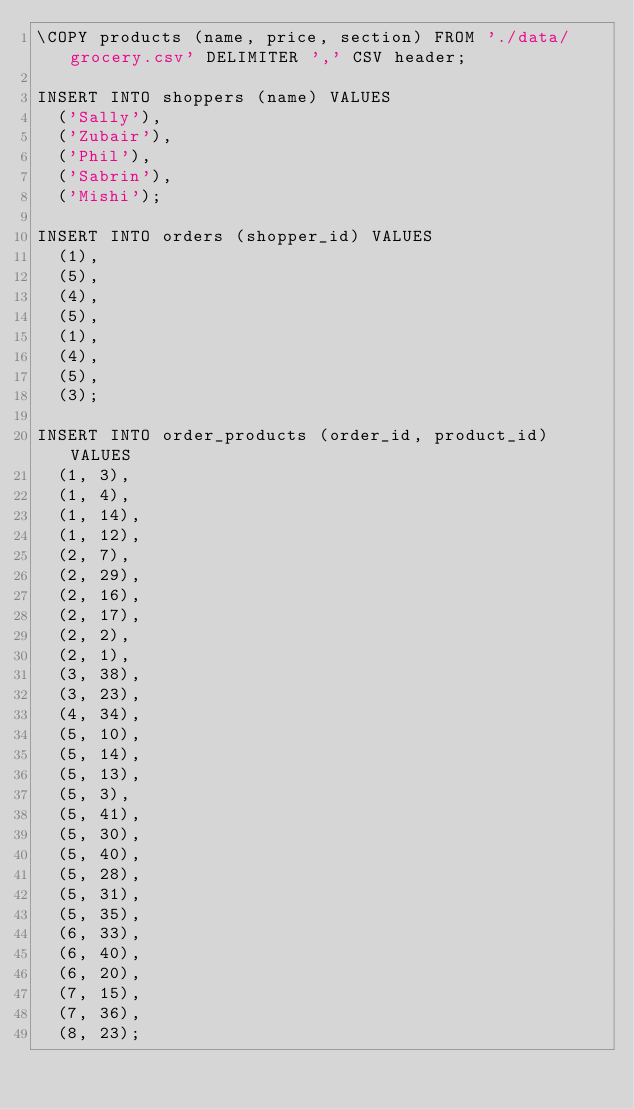<code> <loc_0><loc_0><loc_500><loc_500><_SQL_>\COPY products (name, price, section) FROM './data/grocery.csv' DELIMITER ',' CSV header;

INSERT INTO shoppers (name) VALUES
  ('Sally'),
  ('Zubair'),
  ('Phil'),
  ('Sabrin'),
  ('Mishi');

INSERT INTO orders (shopper_id) VALUES
  (1),
  (5),
  (4),
  (5),
  (1),
  (4),
  (5),
  (3);

INSERT INTO order_products (order_id, product_id) VALUES
  (1, 3),
  (1, 4),
  (1, 14),
  (1, 12),
  (2, 7),
  (2, 29),
  (2, 16),
  (2, 17),
  (2, 2),
  (2, 1),
  (3, 38),
  (3, 23),
  (4, 34),
  (5, 10),
  (5, 14),
  (5, 13),
  (5, 3),
  (5, 41),
  (5, 30),
  (5, 40),
  (5, 28),
  (5, 31),
  (5, 35),
  (6, 33),
  (6, 40),
  (6, 20),
  (7, 15),
  (7, 36),
  (8, 23);
</code> 